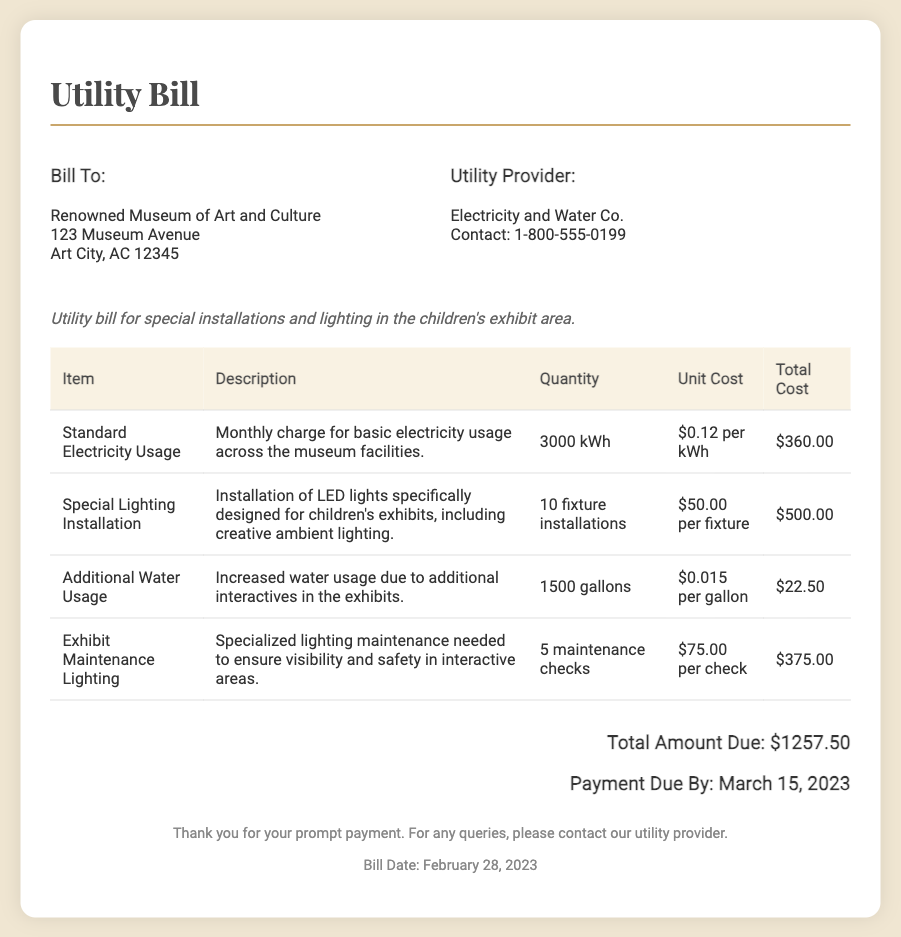What is the total amount due? The total amount due is highlighted at the bottom of the bill.
Answer: $1257.50 When is the payment due? The payment due date is stated in the total section of the document.
Answer: March 15, 2023 Who is the utility provider? The utility provider is mentioned in the header of the document.
Answer: Electricity and Water Co What is the quantity of standard electricity usage? The quantity for standard electricity usage is specified in the table.
Answer: 3000 kWh What is the unit cost for the additional water usage? The unit cost for each gallon of additional water usage is indicated in the table.
Answer: $0.015 per gallon How many fixture installations were made for special lighting? The number of fixtures installed for special lighting is provided in the table.
Answer: 10 fixture installations What type of lighting installation is mentioned in the bill? The bill includes a description of the type of lighting installation provided.
Answer: LED lights How many maintenance checks were conducted for exhibit lighting? The number of maintenance checks is noted in the table section regarding lighting maintenance.
Answer: 5 maintenance checks What was the description for the special lighting installation? The description for the special lighting installation details the specific purpose of the installation.
Answer: Installation of LED lights specifically designed for children's exhibits, including creative ambient lighting 